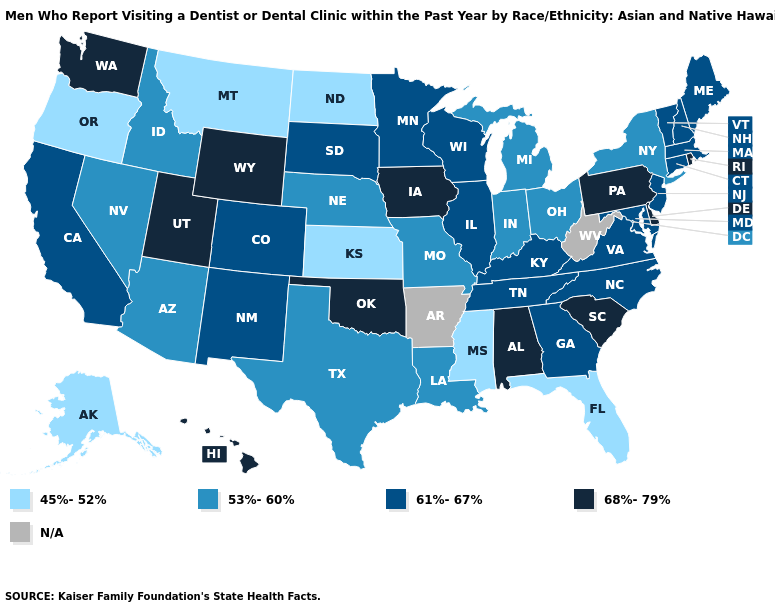Among the states that border Missouri , which have the highest value?
Short answer required. Iowa, Oklahoma. Name the states that have a value in the range 45%-52%?
Write a very short answer. Alaska, Florida, Kansas, Mississippi, Montana, North Dakota, Oregon. Which states hav the highest value in the West?
Give a very brief answer. Hawaii, Utah, Washington, Wyoming. Which states hav the highest value in the South?
Quick response, please. Alabama, Delaware, Oklahoma, South Carolina. What is the value of Michigan?
Short answer required. 53%-60%. What is the value of Pennsylvania?
Write a very short answer. 68%-79%. Among the states that border Oklahoma , which have the highest value?
Concise answer only. Colorado, New Mexico. Name the states that have a value in the range 68%-79%?
Short answer required. Alabama, Delaware, Hawaii, Iowa, Oklahoma, Pennsylvania, Rhode Island, South Carolina, Utah, Washington, Wyoming. Among the states that border Colorado , does New Mexico have the highest value?
Keep it brief. No. Which states have the highest value in the USA?
Give a very brief answer. Alabama, Delaware, Hawaii, Iowa, Oklahoma, Pennsylvania, Rhode Island, South Carolina, Utah, Washington, Wyoming. Among the states that border West Virginia , which have the highest value?
Short answer required. Pennsylvania. What is the value of Maine?
Give a very brief answer. 61%-67%. What is the lowest value in the MidWest?
Give a very brief answer. 45%-52%. 